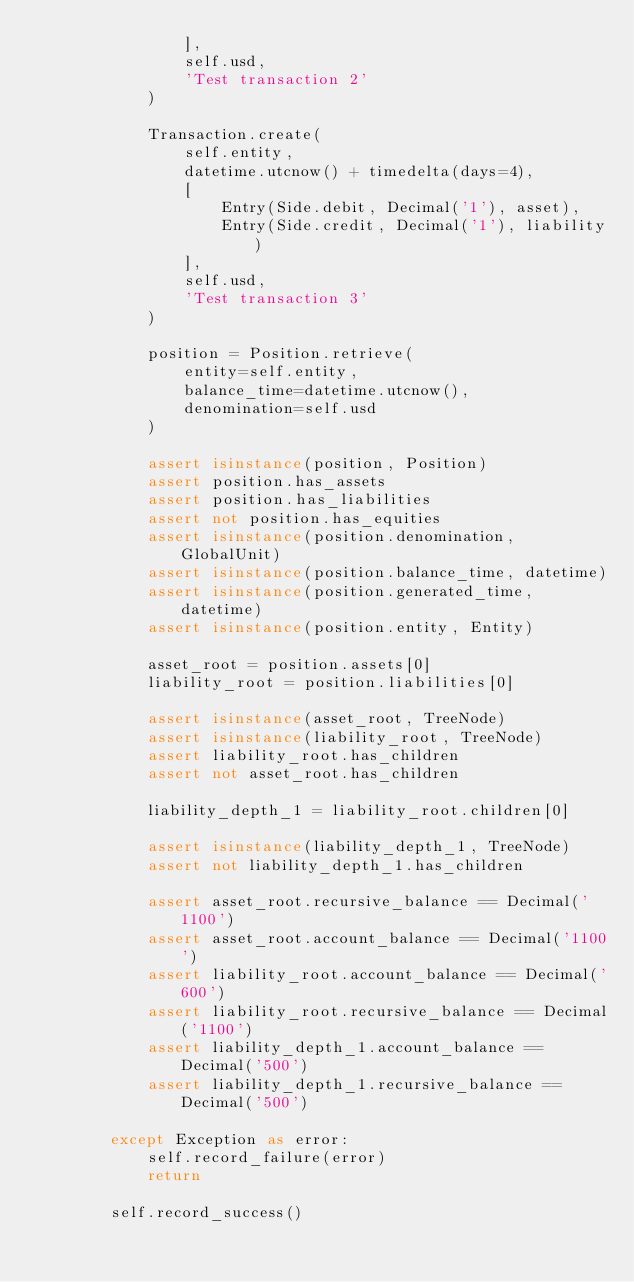<code> <loc_0><loc_0><loc_500><loc_500><_Python_>                ],
                self.usd,
                'Test transaction 2'
            )

            Transaction.create(
                self.entity,
                datetime.utcnow() + timedelta(days=4),
                [
                    Entry(Side.debit, Decimal('1'), asset),
                    Entry(Side.credit, Decimal('1'), liability)
                ],
                self.usd,
                'Test transaction 3'
            )

            position = Position.retrieve(
                entity=self.entity,
                balance_time=datetime.utcnow(),
                denomination=self.usd
            )

            assert isinstance(position, Position)
            assert position.has_assets
            assert position.has_liabilities
            assert not position.has_equities
            assert isinstance(position.denomination, GlobalUnit)
            assert isinstance(position.balance_time, datetime)
            assert isinstance(position.generated_time, datetime)
            assert isinstance(position.entity, Entity)

            asset_root = position.assets[0]
            liability_root = position.liabilities[0]

            assert isinstance(asset_root, TreeNode)
            assert isinstance(liability_root, TreeNode)
            assert liability_root.has_children
            assert not asset_root.has_children

            liability_depth_1 = liability_root.children[0]

            assert isinstance(liability_depth_1, TreeNode)
            assert not liability_depth_1.has_children

            assert asset_root.recursive_balance == Decimal('1100')
            assert asset_root.account_balance == Decimal('1100')
            assert liability_root.account_balance == Decimal('600')
            assert liability_root.recursive_balance == Decimal('1100')
            assert liability_depth_1.account_balance == Decimal('500')
            assert liability_depth_1.recursive_balance == Decimal('500')

        except Exception as error:
            self.record_failure(error)
            return

        self.record_success()
</code> 